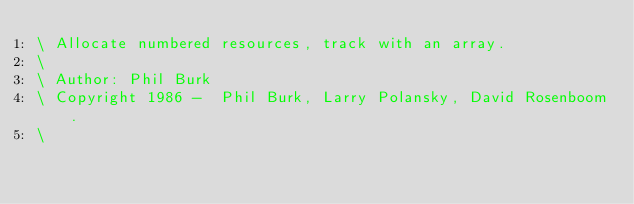Convert code to text. <code><loc_0><loc_0><loc_500><loc_500><_Forth_>\ Allocate numbered resources, track with an array.
\
\ Author: Phil Burk
\ Copyright 1986 -  Phil Burk, Larry Polansky, David Rosenboom.
\</code> 